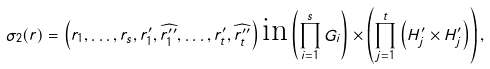Convert formula to latex. <formula><loc_0><loc_0><loc_500><loc_500>\sigma _ { 2 } ( r ) = \left ( r _ { 1 } , \dots , r _ { s } , r _ { 1 } ^ { \prime } , \widehat { r _ { 1 } ^ { \prime \prime } } , \dots , r _ { t } ^ { \prime } , \widehat { r _ { t } ^ { \prime \prime } } \right ) \text {in} \left ( \prod _ { i = 1 } ^ { s } G _ { i } \right ) \times \left ( \prod _ { j = 1 } ^ { t } \left ( H ^ { \prime } _ { j } \times H ^ { \prime } _ { j } \right ) \right ) ,</formula> 